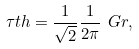<formula> <loc_0><loc_0><loc_500><loc_500>\tau t h = \frac { 1 } { \sqrt { 2 } } \frac { 1 } { 2 \pi } \ G r ,</formula> 